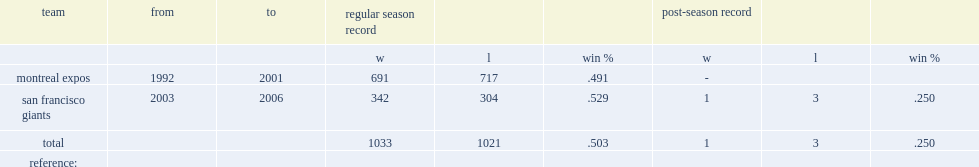When did felipe alou manage the montreal expos? 1992 2001. 